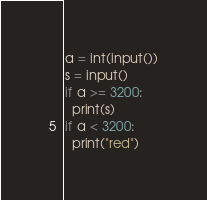<code> <loc_0><loc_0><loc_500><loc_500><_Python_>a = int(input())
s = input()
if a >= 3200:
  print(s)
if a < 3200:
  print("red")
</code> 